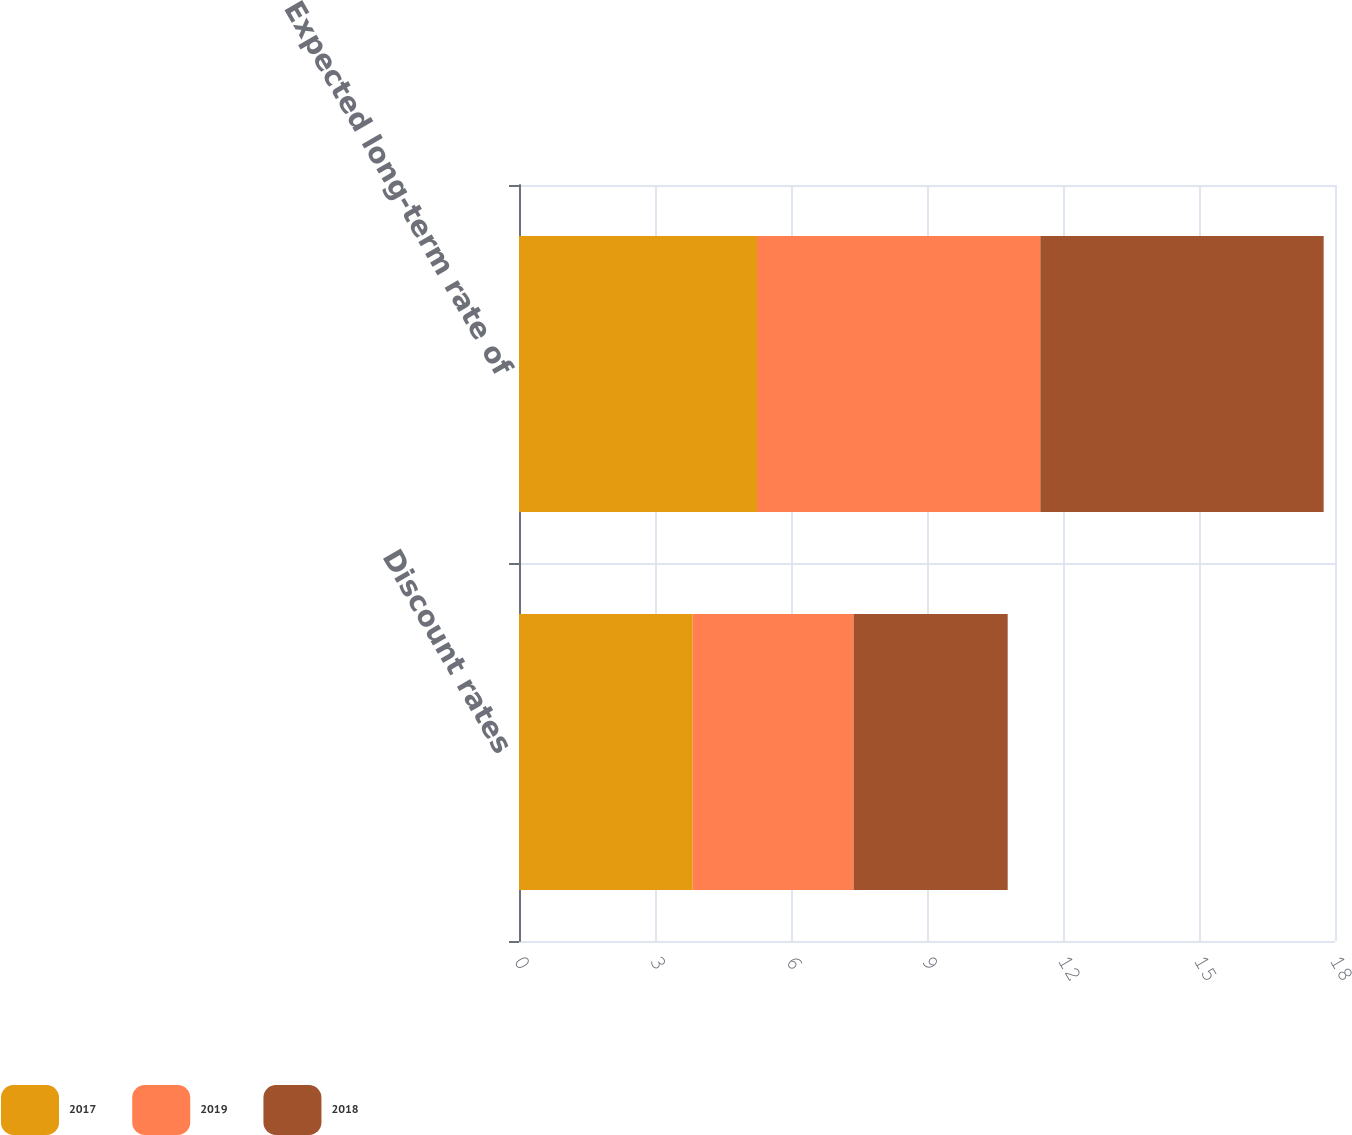Convert chart to OTSL. <chart><loc_0><loc_0><loc_500><loc_500><stacked_bar_chart><ecel><fcel>Discount rates<fcel>Expected long-term rate of<nl><fcel>2017<fcel>3.83<fcel>5.25<nl><fcel>2019<fcel>3.55<fcel>6.25<nl><fcel>2018<fcel>3.4<fcel>6.25<nl></chart> 